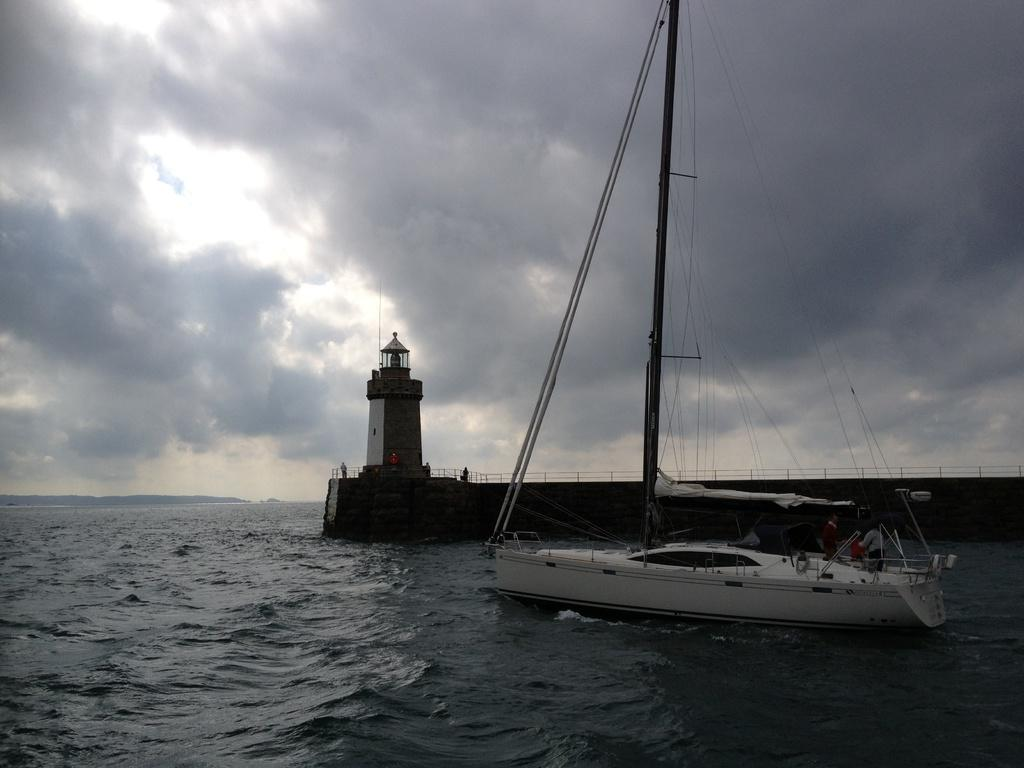What is located on the right side of the image? There is a ship on the right side of the image. Where is the ship situated? The ship is on the water. What can be seen in the center of the image? There is a tower in the center of the image. What is visible at the bottom of the image? Water is visible at the bottom side of the image. Can you see any fangs on the ship in the image? There are no fangs present in the image, as it features a ship on the water and a tower in the center. What type of cheese is being used to build the tower in the image? There is no cheese present in the image; the tower is a separate structure. 